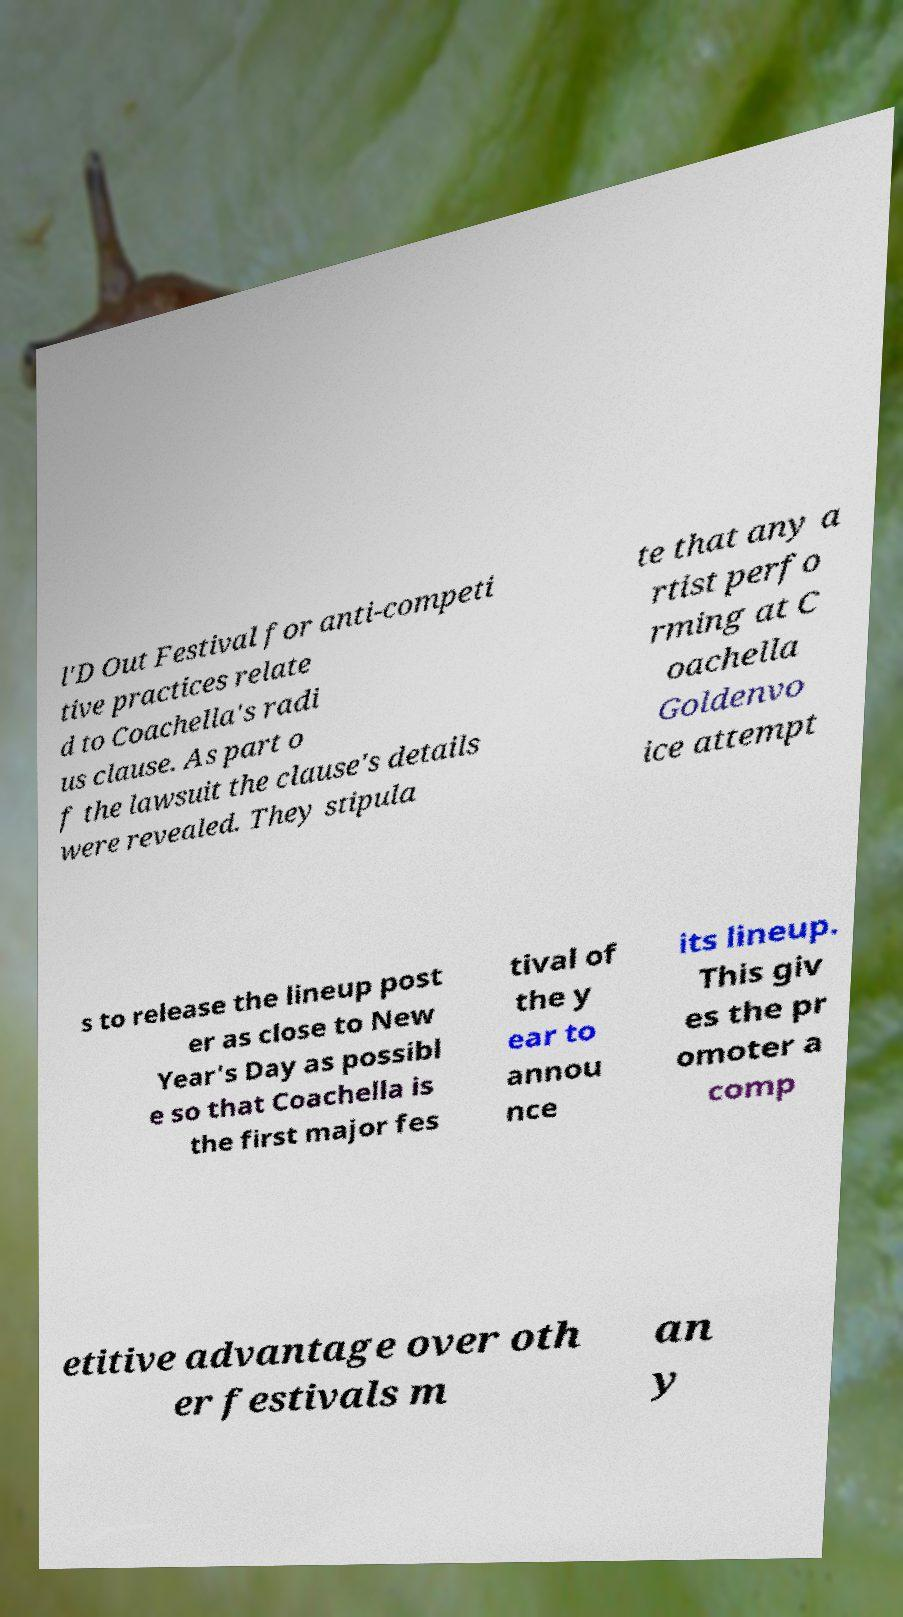Please identify and transcribe the text found in this image. l'D Out Festival for anti-competi tive practices relate d to Coachella's radi us clause. As part o f the lawsuit the clause's details were revealed. They stipula te that any a rtist perfo rming at C oachella Goldenvo ice attempt s to release the lineup post er as close to New Year's Day as possibl e so that Coachella is the first major fes tival of the y ear to annou nce its lineup. This giv es the pr omoter a comp etitive advantage over oth er festivals m an y 